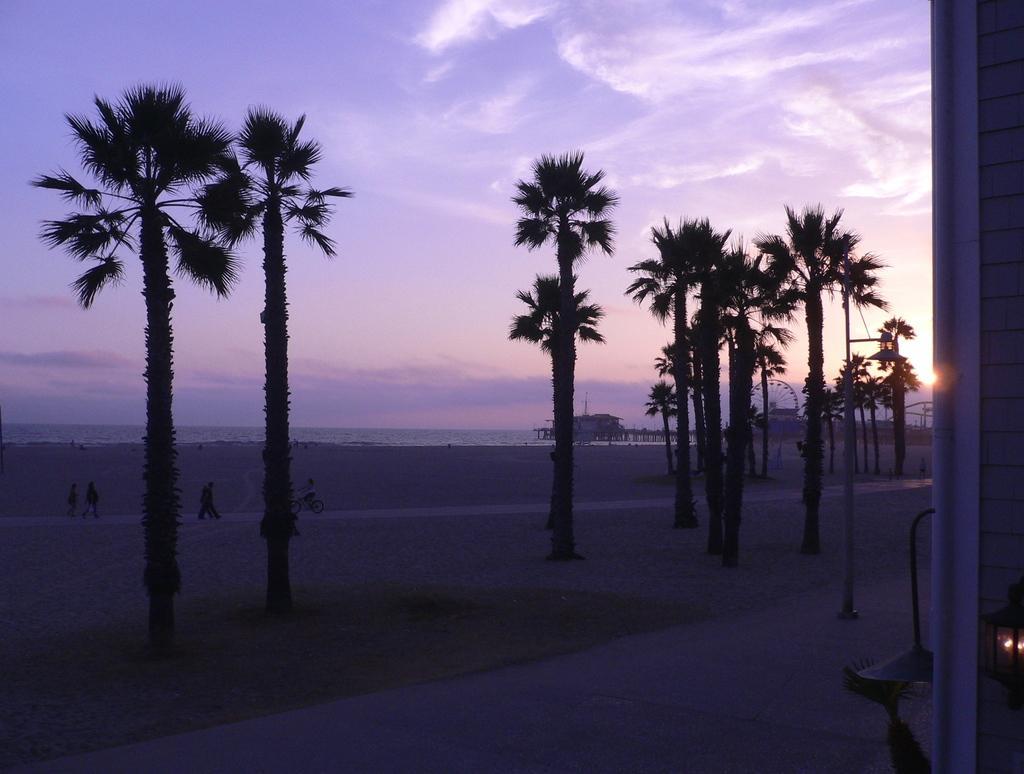Describe this image in one or two sentences. In this image we can see a few people and there is a person riding a bicycle and we can see some trees and there is a wall on the right side of the image. In the background, we can see the water and there is a house and giant wheel and at the top we can see the sky. 